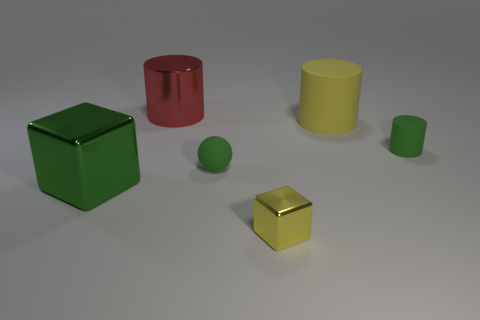Add 1 small yellow cubes. How many objects exist? 7 Subtract all spheres. How many objects are left? 5 Subtract all big yellow things. Subtract all metal blocks. How many objects are left? 3 Add 6 tiny metallic blocks. How many tiny metallic blocks are left? 7 Add 3 large green things. How many large green things exist? 4 Subtract 0 red balls. How many objects are left? 6 